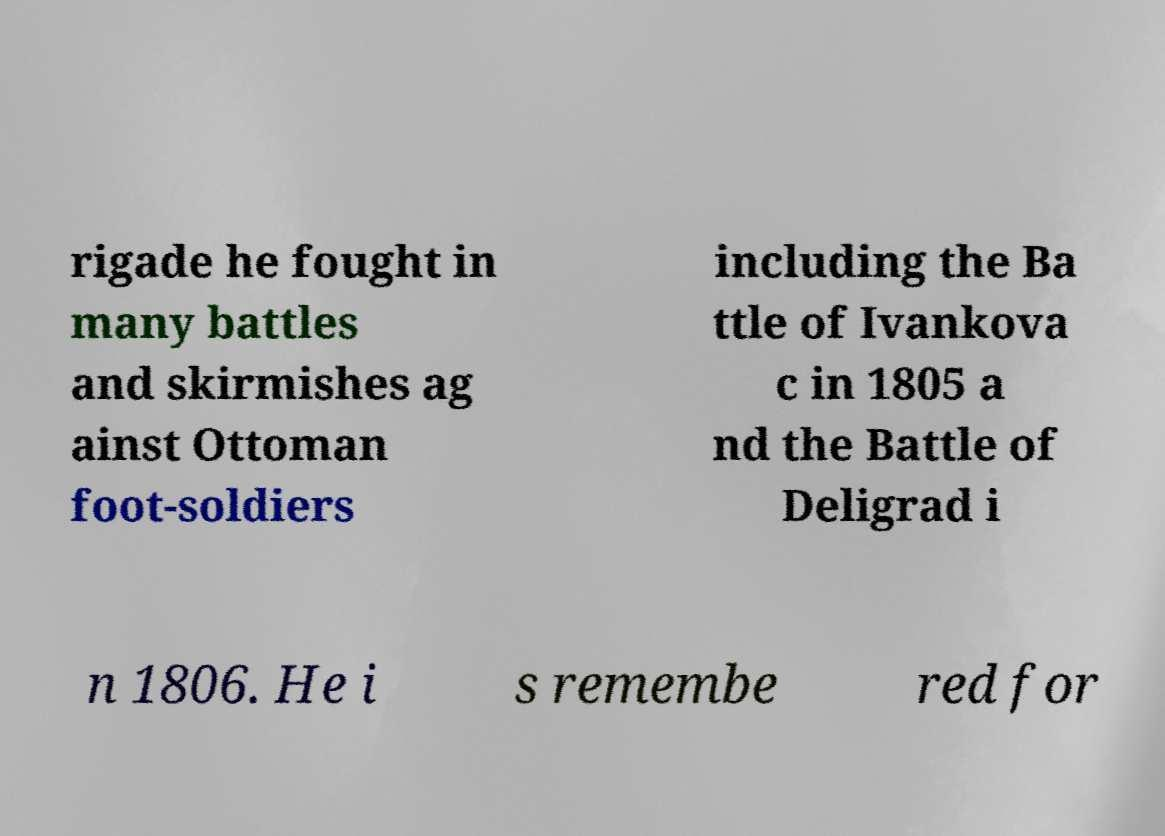What messages or text are displayed in this image? I need them in a readable, typed format. rigade he fought in many battles and skirmishes ag ainst Ottoman foot-soldiers including the Ba ttle of Ivankova c in 1805 a nd the Battle of Deligrad i n 1806. He i s remembe red for 